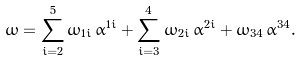Convert formula to latex. <formula><loc_0><loc_0><loc_500><loc_500>\omega = \sum _ { i = 2 } ^ { 5 } \omega _ { 1 i } \, \alpha ^ { 1 i } + \sum _ { i = 3 } ^ { 4 } \omega _ { 2 i } \, \alpha ^ { 2 i } + \omega _ { 3 4 } \, \alpha ^ { 3 4 } .</formula> 